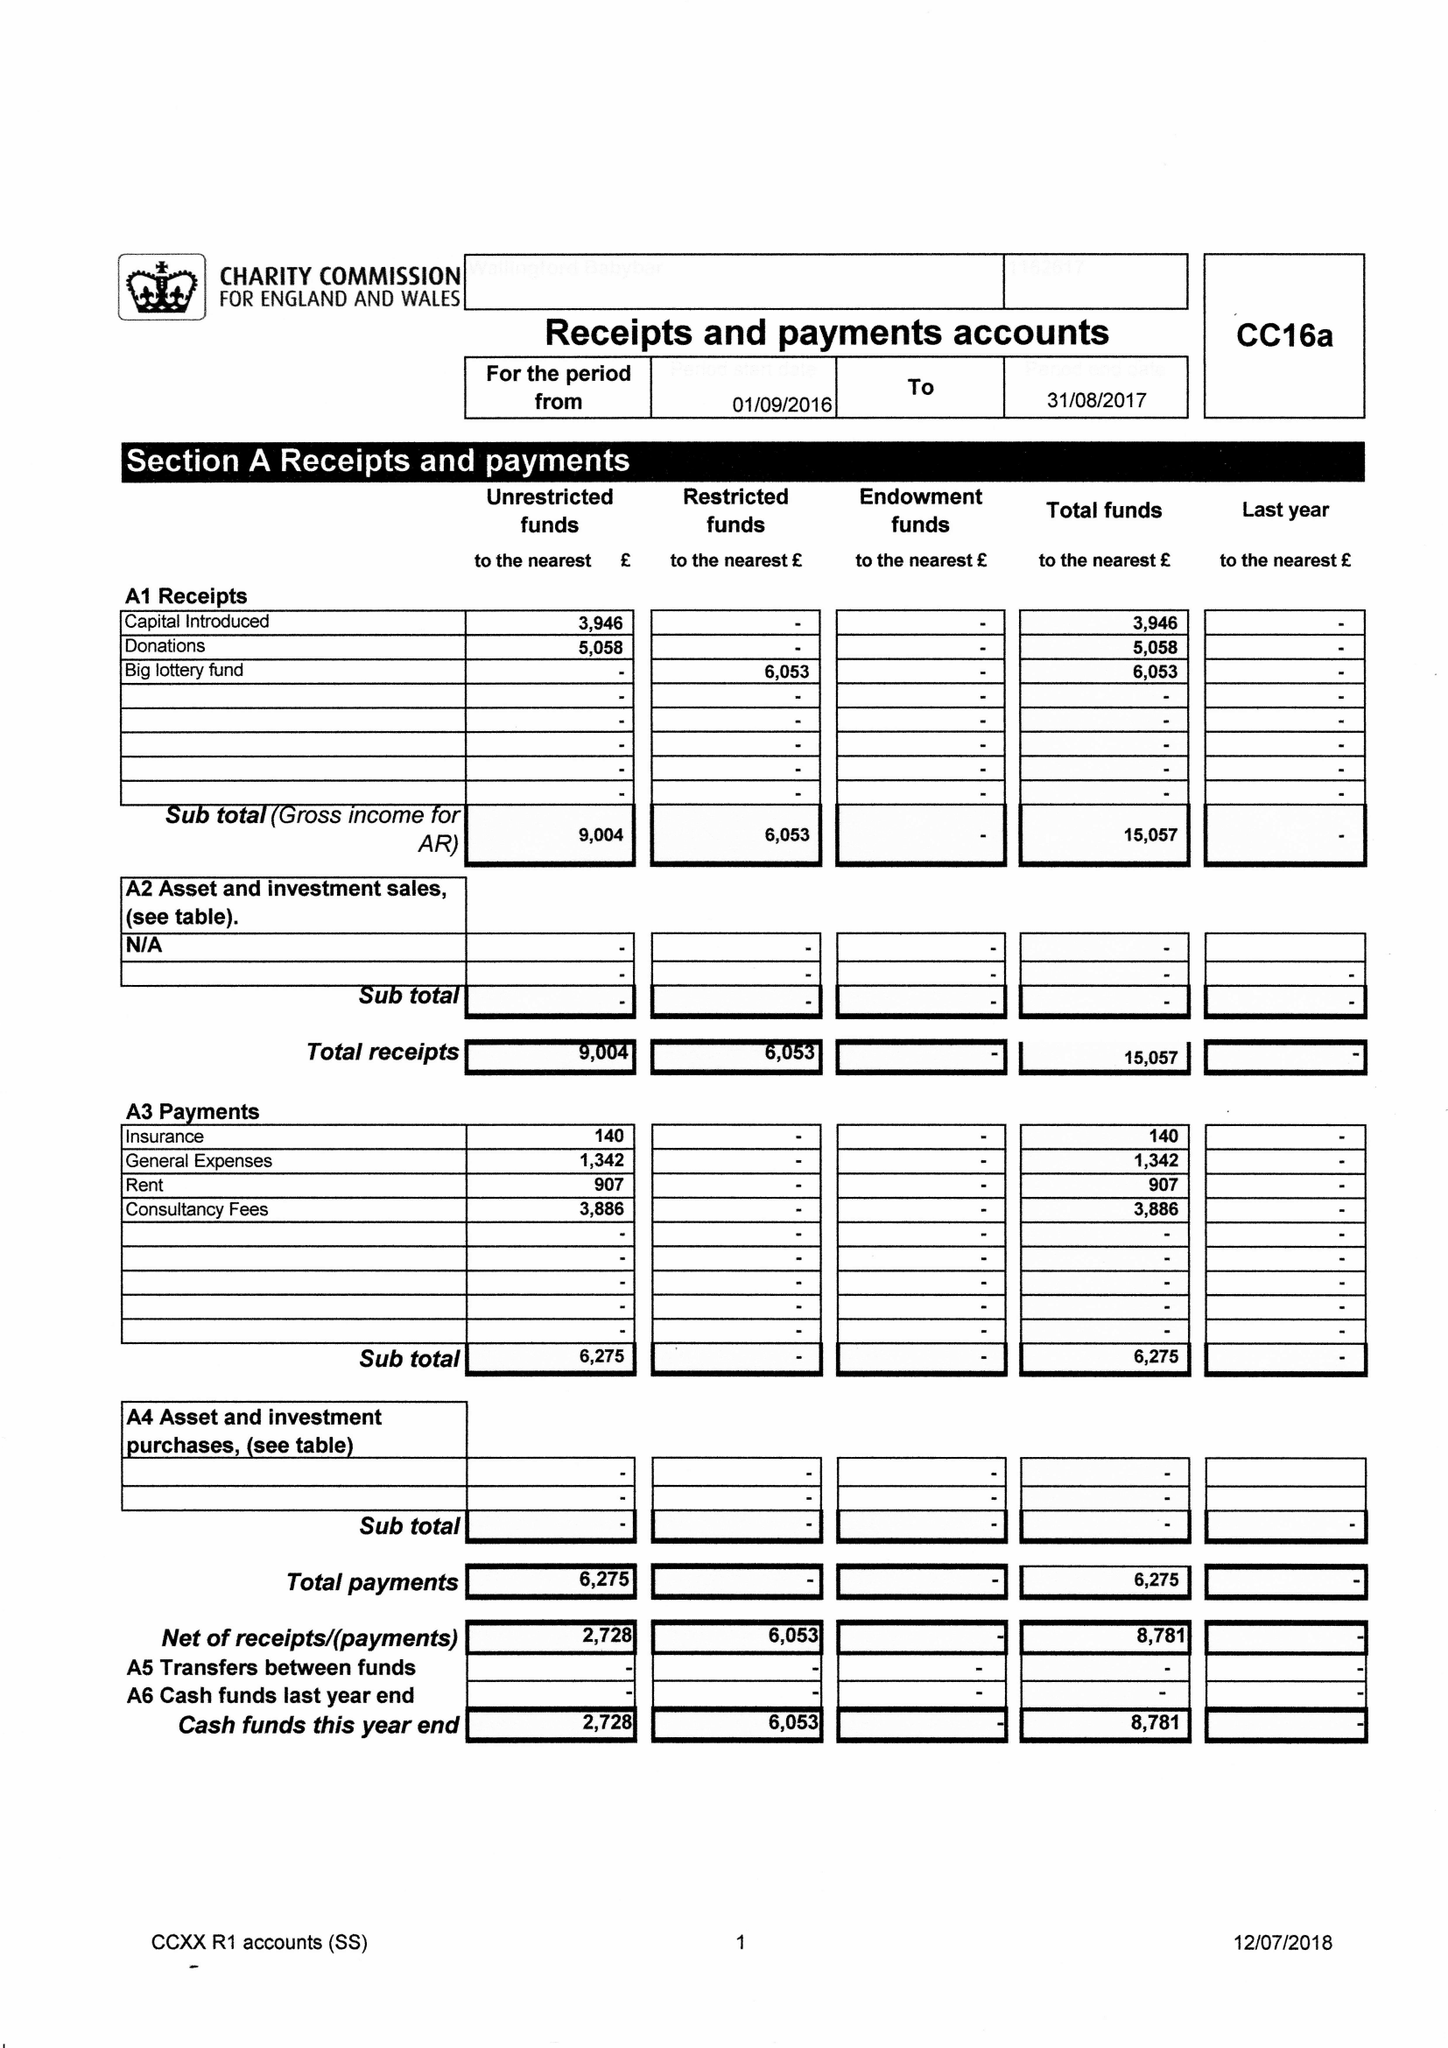What is the value for the charity_number?
Answer the question using a single word or phrase. 1162617 